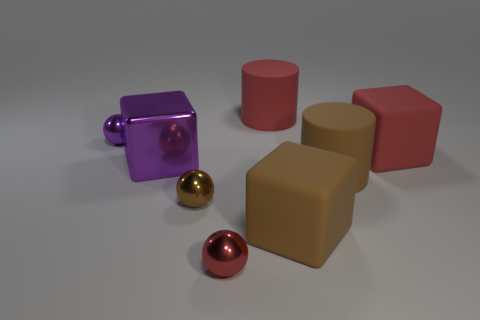The big purple metallic thing has what shape? The large purple object appears to be a cube, characterized by its six equally-sized square faces and sharp edges. 